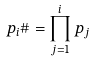Convert formula to latex. <formula><loc_0><loc_0><loc_500><loc_500>p _ { i } \# = \prod _ { j = 1 } ^ { i } p _ { j }</formula> 